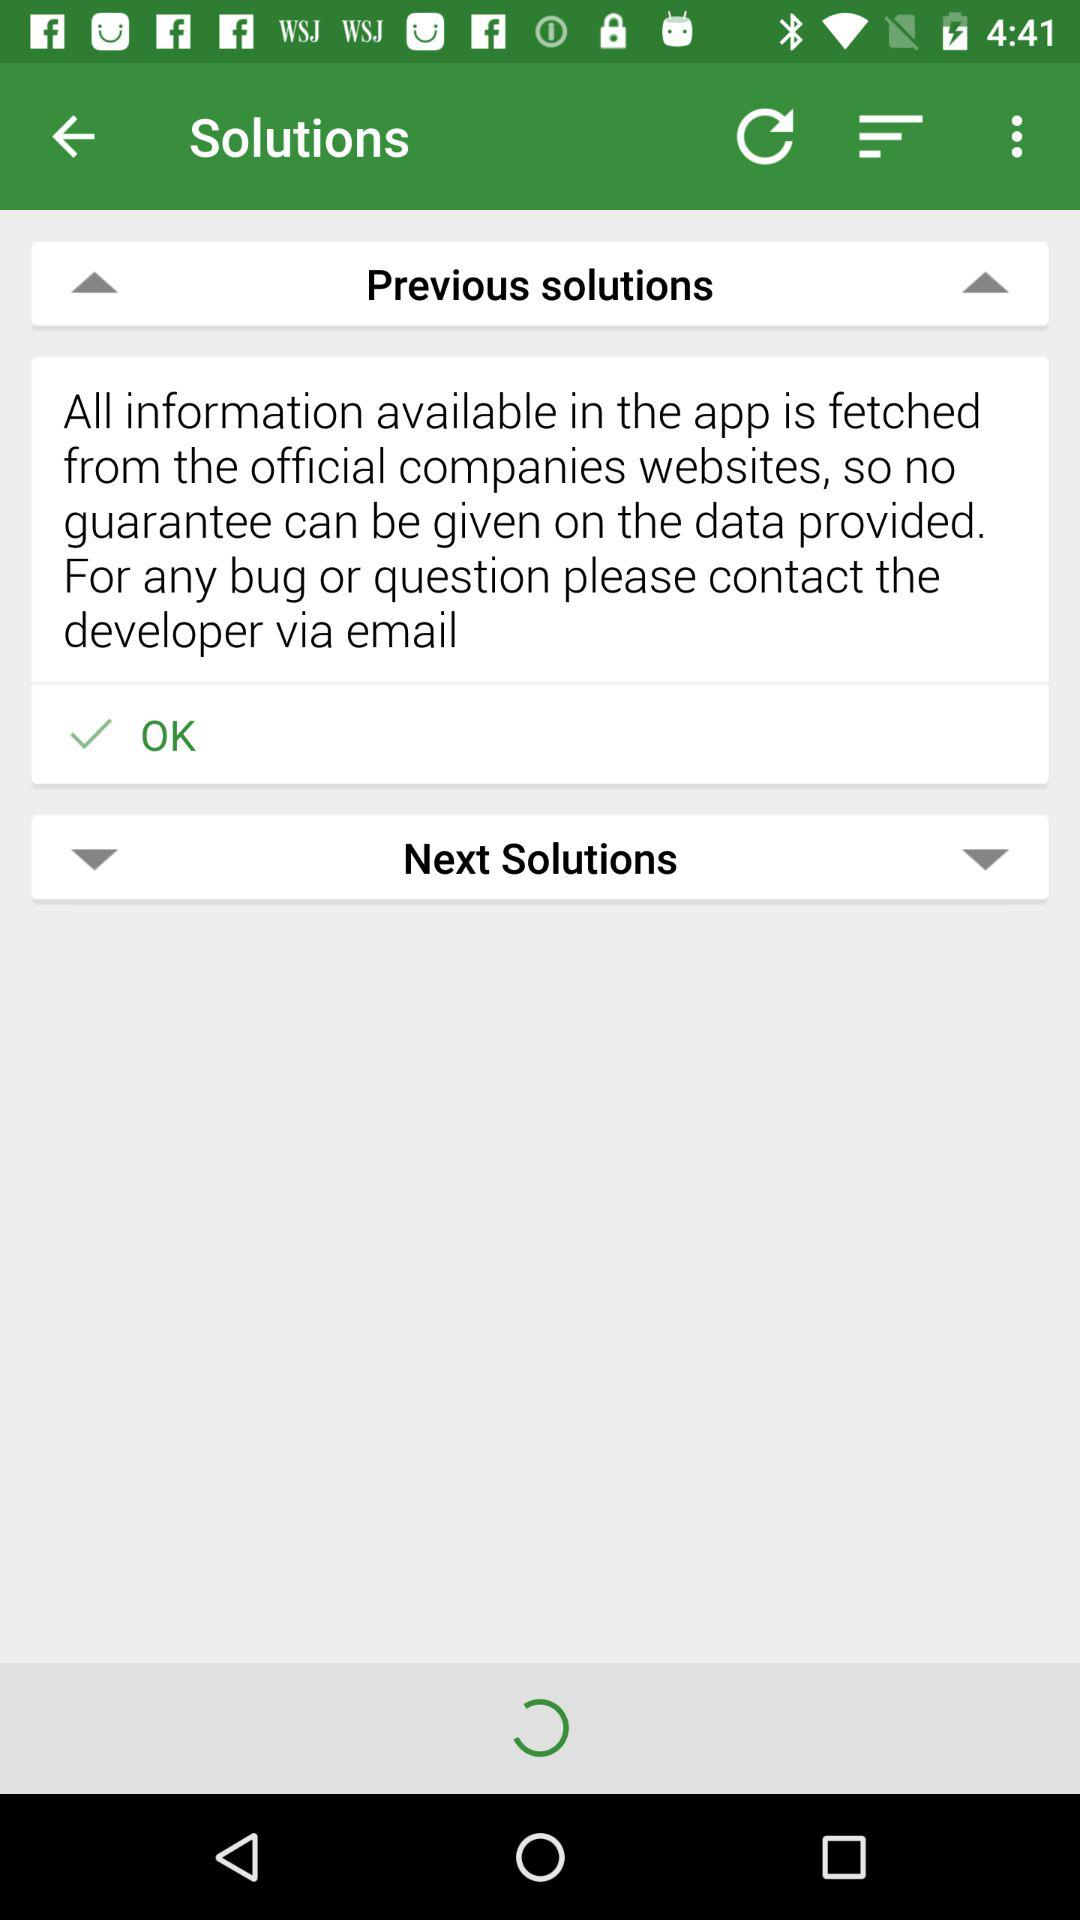What is the selected checkbox? The selected checkbox is "OK". 